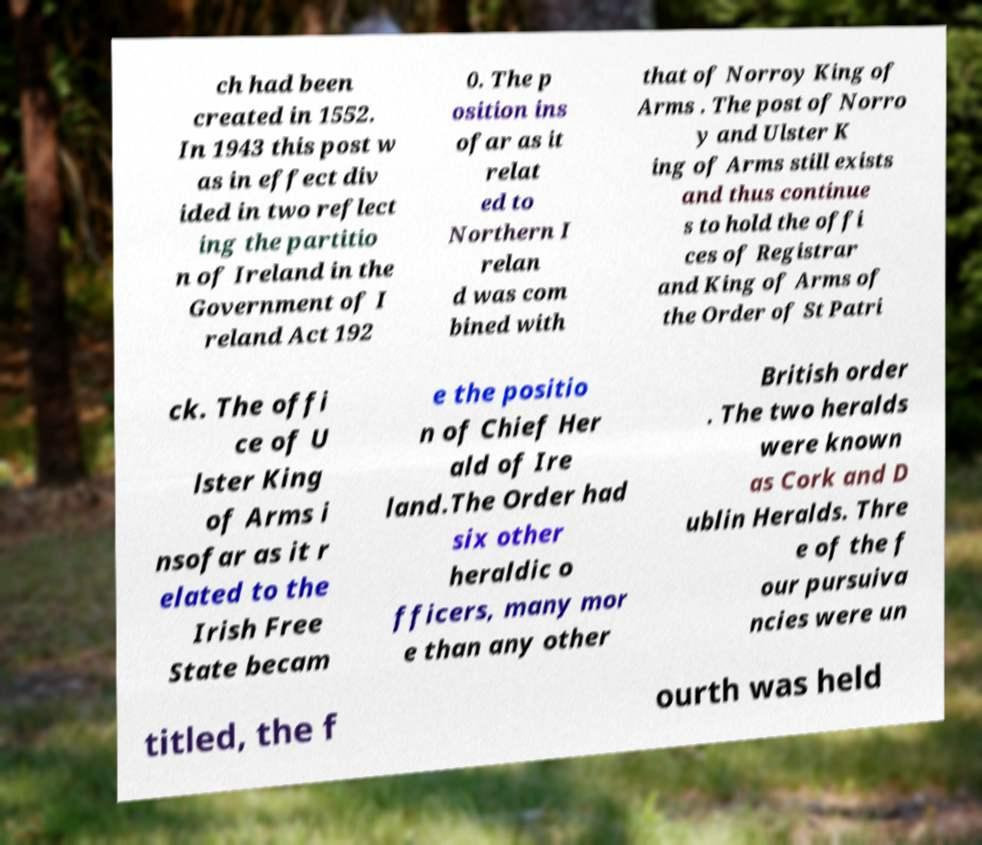What messages or text are displayed in this image? I need them in a readable, typed format. ch had been created in 1552. In 1943 this post w as in effect div ided in two reflect ing the partitio n of Ireland in the Government of I reland Act 192 0. The p osition ins ofar as it relat ed to Northern I relan d was com bined with that of Norroy King of Arms . The post of Norro y and Ulster K ing of Arms still exists and thus continue s to hold the offi ces of Registrar and King of Arms of the Order of St Patri ck. The offi ce of U lster King of Arms i nsofar as it r elated to the Irish Free State becam e the positio n of Chief Her ald of Ire land.The Order had six other heraldic o fficers, many mor e than any other British order . The two heralds were known as Cork and D ublin Heralds. Thre e of the f our pursuiva ncies were un titled, the f ourth was held 